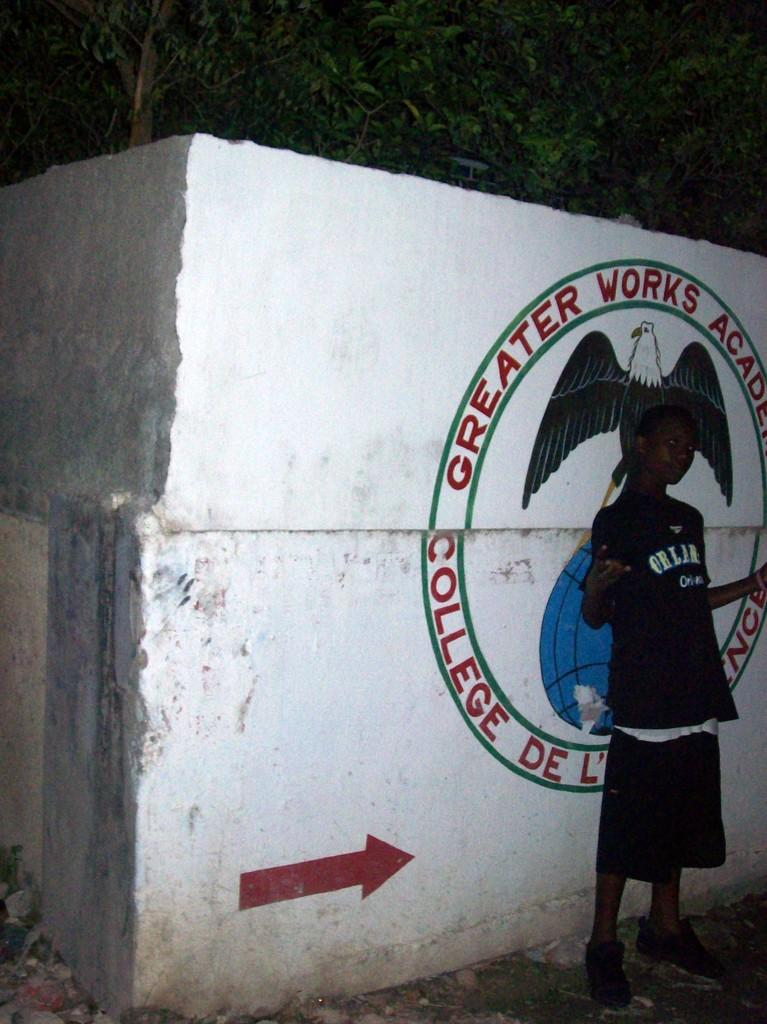Provide a one-sentence caption for the provided image. A person poses in front of a Greater Works Academy logo. 